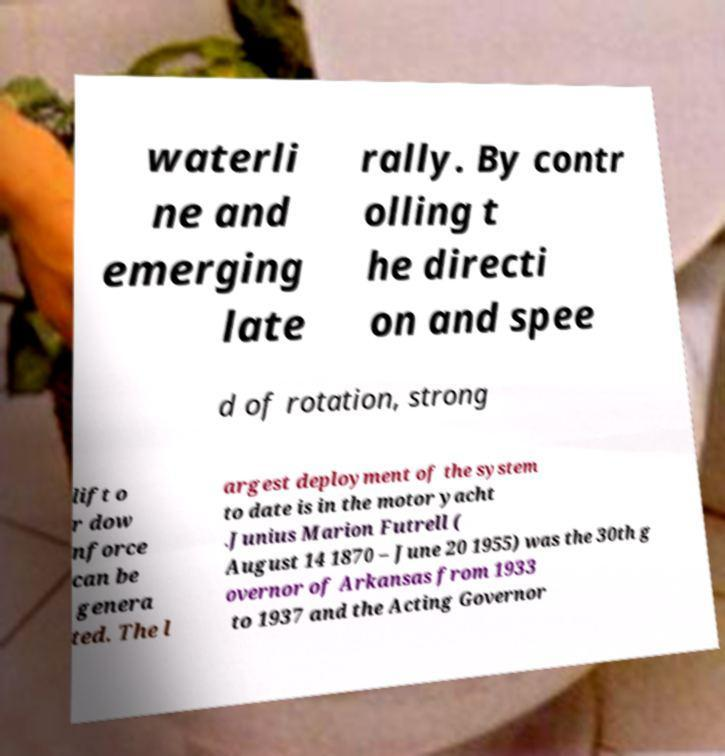Can you read and provide the text displayed in the image?This photo seems to have some interesting text. Can you extract and type it out for me? waterli ne and emerging late rally. By contr olling t he directi on and spee d of rotation, strong lift o r dow nforce can be genera ted. The l argest deployment of the system to date is in the motor yacht .Junius Marion Futrell ( August 14 1870 – June 20 1955) was the 30th g overnor of Arkansas from 1933 to 1937 and the Acting Governor 